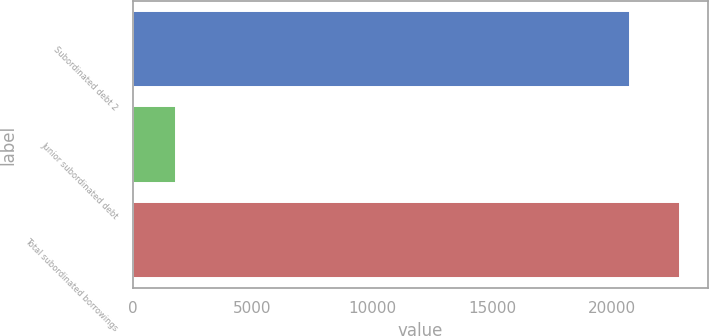Convert chart to OTSL. <chart><loc_0><loc_0><loc_500><loc_500><bar_chart><fcel>Subordinated debt 2<fcel>Junior subordinated debt<fcel>Total subordinated borrowings<nl><fcel>20784<fcel>1817<fcel>22862.4<nl></chart> 